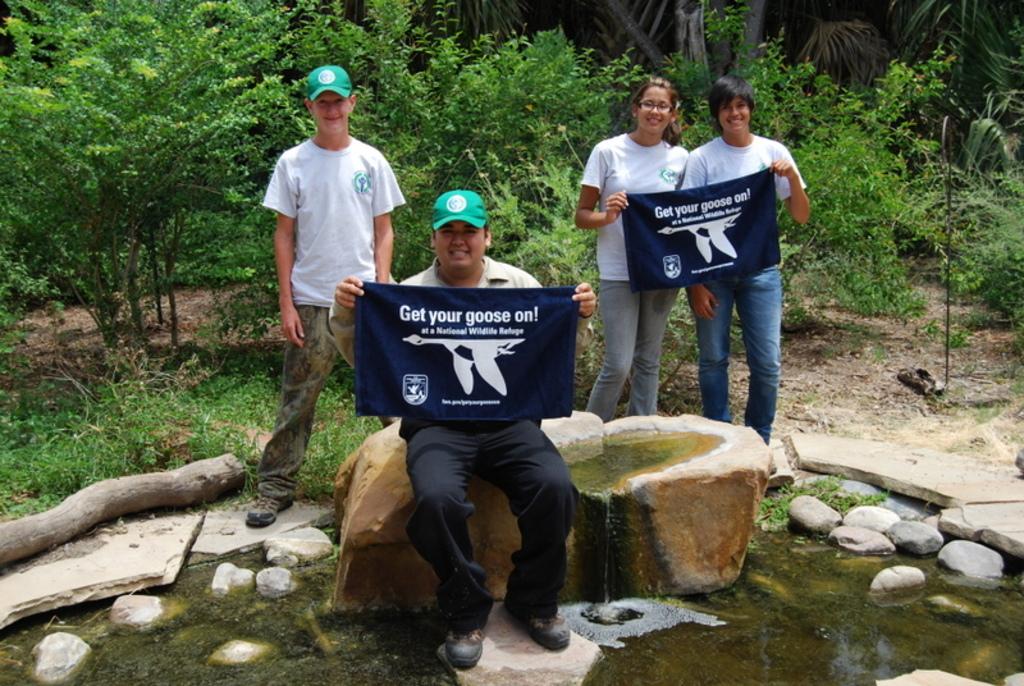Get your what on?
Offer a terse response. Goose. What does the top line of text say?
Your response must be concise. Get your goose on!. 